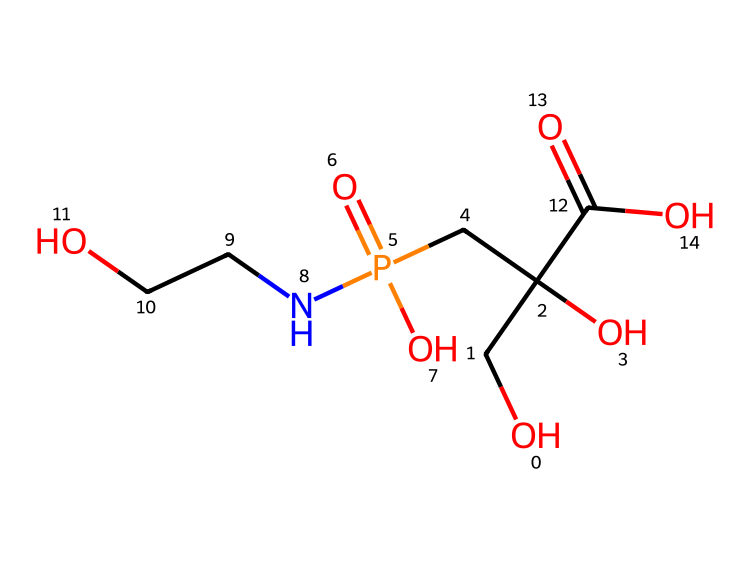What is the molecular formula of glyphosate? To determine the molecular formula, we analyze the SMILES representation by counting the different types of atoms present. The elements present in glyphosate include carbon (C), hydrogen (H), nitrogen (N), oxygen (O), and phosphorus (P). Based on the counts, the molecular formula is C3H8N5O5P.
Answer: C3H8N5O5P How many carbon atoms are in glyphosate? By counting the occurrences of the carbon (C) atom in the SMILES, we find that there are three carbon atoms in glyphosate.
Answer: 3 What functional groups are present in glyphosate? Analyzing the structure in the SMILES, we identify functional groups typical to the compound, such as an amine (due to the nitrogen), carboxylic acid (due to the -COOH groups), and phosphate (due to the phosphorus and surrounding oxygens). These groups contribute to the properties of glyphosate.
Answer: amine, carboxylic acid, phosphate How many oxygen atoms are in glyphosate? By assessing the SMILES, we can count the number of oxygen (O) atoms present. In glyphosate, there are five oxygen atoms.
Answer: 5 What property allows glyphosate to target specific plants? The unique structure of glyphosate, particularly its ability to inhibit certain enzymes in the shikimic acid pathway, allows it to target specific plants (broadleaf and grasses) without affecting others, such as cereals, which do not have this pathway.
Answer: inhibition of shikimic acid pathway Which part of glyphosate is responsible for its herbicidal activity? The phosphonate functional group within the glyphosate structure closely interacts with a particular enzyme in target plants, inhibiting it and thus providing its herbicidal properties. Other parts of the molecule also help with solubility and transport.
Answer: phosphonate functional group 